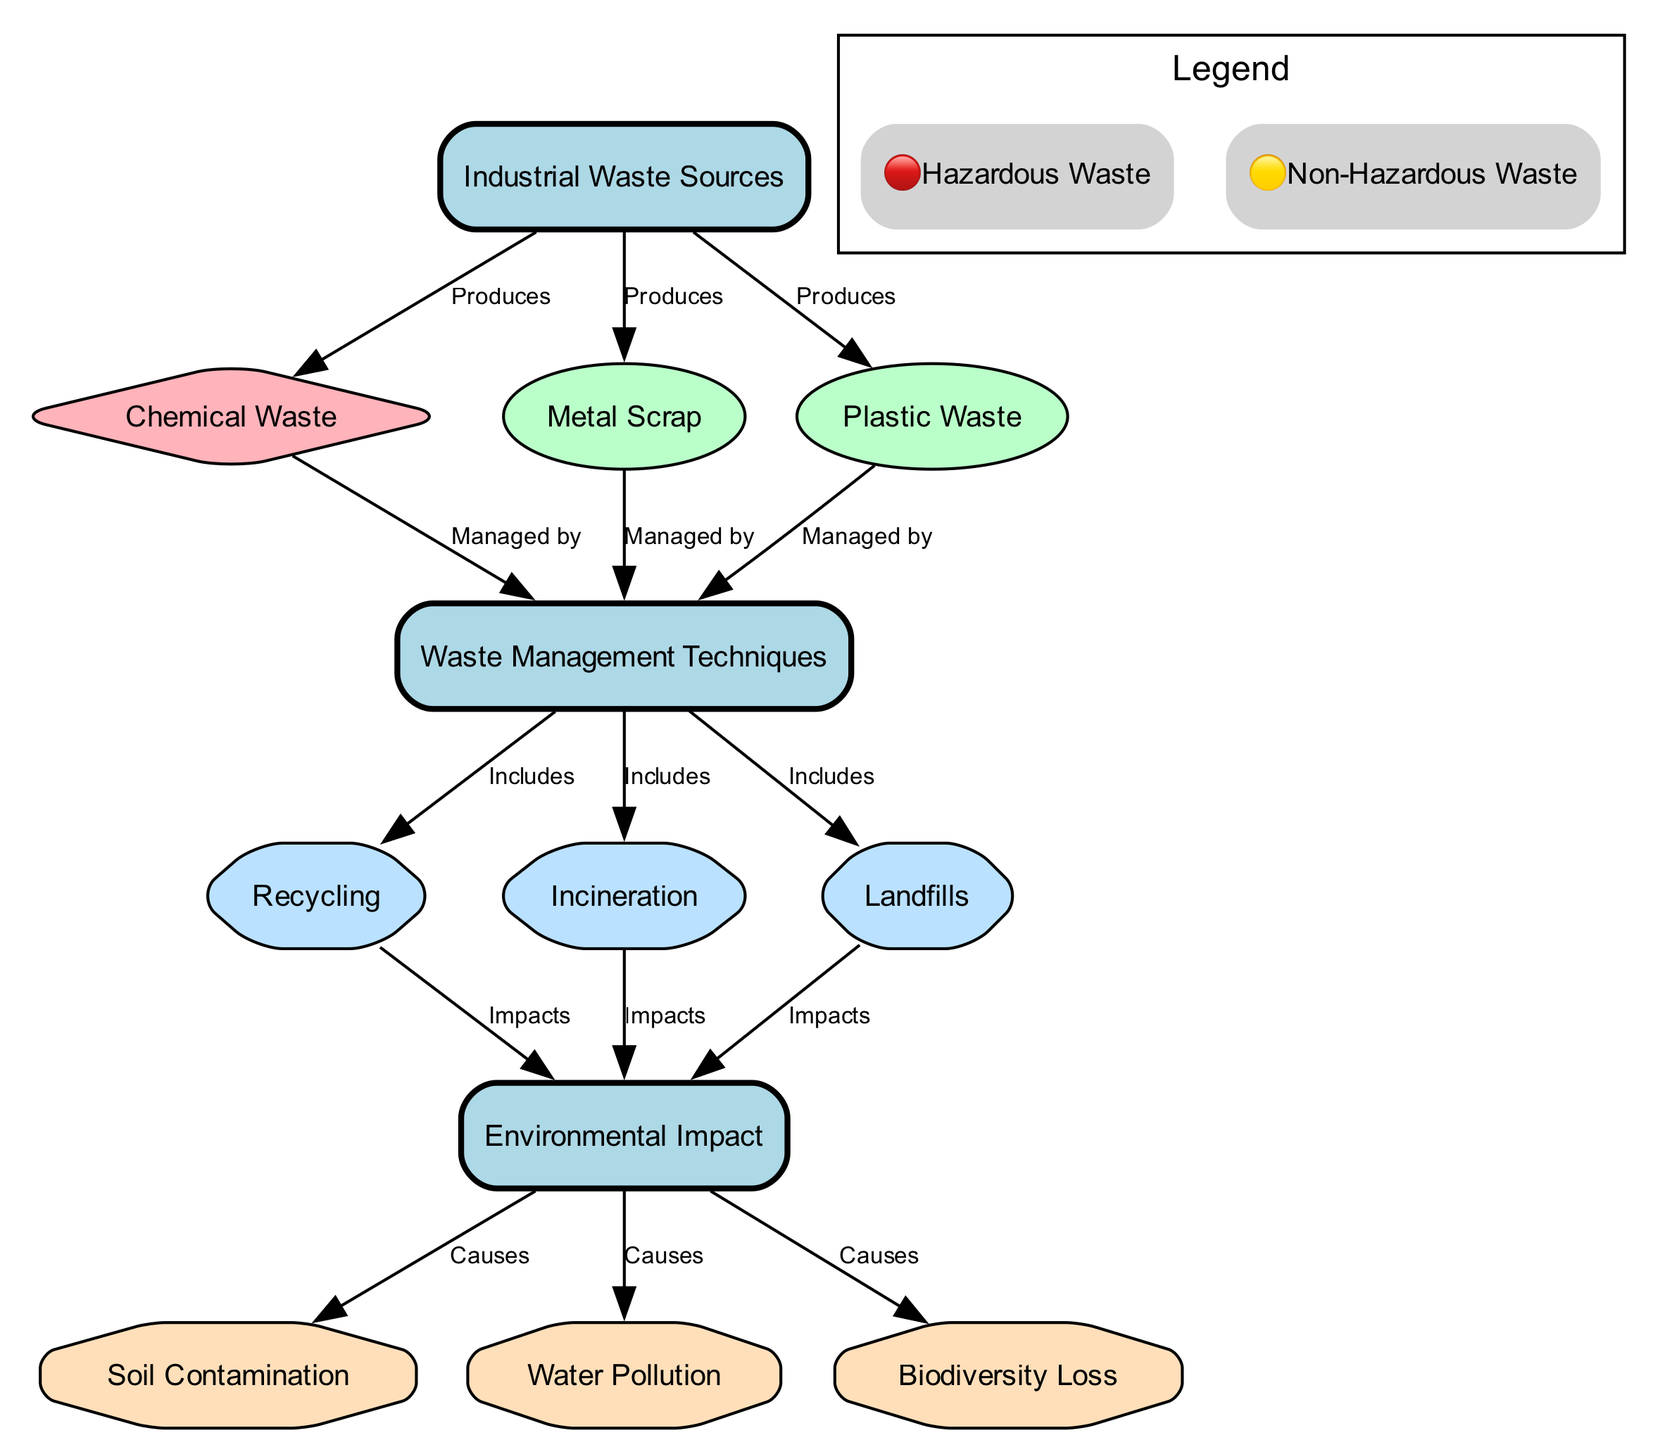What are the types of waste produced by industrial sources? The diagram indicates that chemical waste, metal scrap, and plastic waste are produced by industrial sources. These are listed as nodes directly connected to "Industrial Waste Sources."
Answer: Chemical waste, metal scrap, plastic waste How many waste management techniques are shown in the diagram? The diagram lists three techniques for waste management: recycling, incineration, and landfills. Each one is represented as a node under "Waste Management Techniques."
Answer: Three What is the relationship between chemical waste and waste management techniques? The diagram shows that chemical waste is "Managed by" waste management techniques. This is established by the directed edge from "Chemical Waste" to "Waste Management Techniques."
Answer: Managed by Which waste management technique is linked to the impact on biodiversity? The diagram indicates that waste management techniques such as recycling, incineration, and landfills all "Impacts" the environmental effects, notably leading to biodiversity loss. This is detailed by edges from these techniques to "Environmental Impact."
Answer: Recycling, incineration, landfills What type of hazard is represented by the connections from "Environmental Impact"? The connections from "Environmental Impact" show that it causes soil contamination, water pollution, and biodiversity loss, each represented as a hazard type in octagonal nodes.
Answer: Soil contamination, water pollution, biodiversity loss What does the symbol 🔴 signify in the diagram? According to the legend in the diagram, the symbol 🔴 is defined as indicating "Hazardous Waste." It serves as a key for understanding the types of waste represented in hazardous conditions.
Answer: Hazardous Waste Which waste produces the highest environmental hazard according to the diagram? The diagram shows that chemical waste is classified as hazardous and is linked directly to "Environmental Impact," which leads to serious hazards like soil contamination, water pollution, and biodiversity loss. Therefore, it is inferred to produce the highest environmental hazard.
Answer: Chemical Waste How many types of waste management techniques are illustrated in the diagram? The diagram illustrates three types of waste management techniques: recycling, incineration, and landfills, all connected under "Waste Management Techniques."
Answer: Three What are the outcomes caused by "Environmental Impact"? The diagram explicitly states that "Environmental Impact" leads to soil contamination, water pollution, and biodiversity loss. These outcomes are represented by connections from the "Environmental Impact" node to the corresponding hazard nodes.
Answer: Soil contamination, water pollution, biodiversity loss 